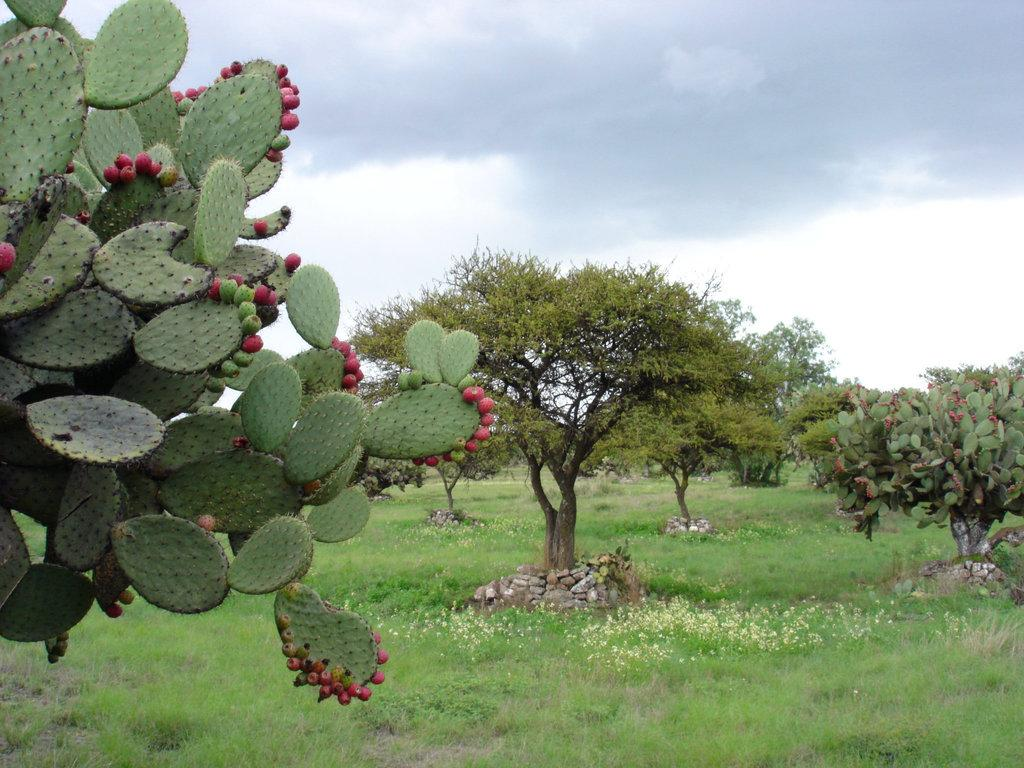What type of vegetation can be seen in the image? There are trees in the image. What is present at the bottom of the image? There are rocks and grass at the bottom of the image. What can be seen in the background of the image? The sky is visible in the background of the image. What type of hat is the father wearing in the image? There is no father or hat present in the image. Can you see any zebras in the image? There are no zebras present in the image. 